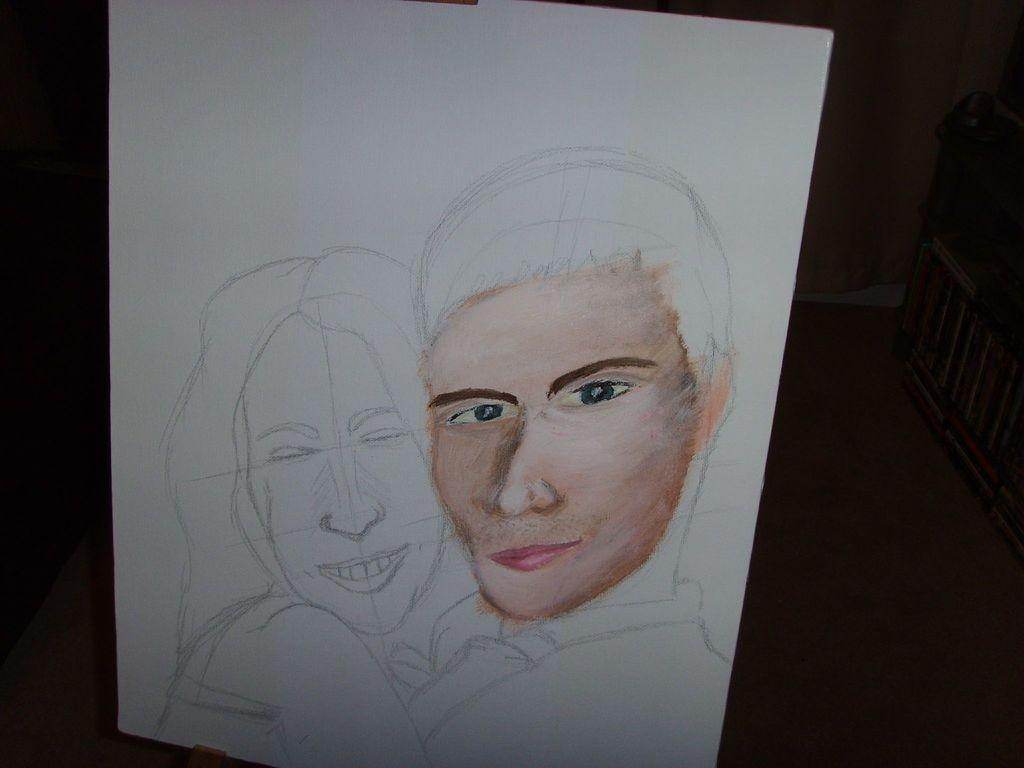What is the main subject of the image? The main subject of the image is a paper. What is depicted on the paper? The paper contains a sketch of a lady and a man. How would you describe the lighting in the image? The background of the image is dark. What grade did the artist receive for their sketch of the lady and man? There is no information about the artist's grade in the image. --- Facts: 1. There is a car in the image. 2. The car is parked on the street. 3. There are trees in the background of the image. 4. The sky is visible in the image. Absurd Topics: dance, ocean, jump Conversation: What is the main subject of the image? The main subject of the image is a car. Where is the car located in the image? The car is parked on the street. What can be seen in the background of the image? There are trees in the background of the image. What is visible at the top of the image? The sky is visible in the image. Reasoning: Let's think step by step in order to produce the conversation. We start by identifying the main subject of the image, which is the car. Then, we describe the location of the car, noting that it is parked on the street. Next, we address the background of the image, which includes trees. Finally, we mention the sky, which is visible at the top of the image. Absurd Question/Answer: Can you see the ocean in the background of the image? No, there is no ocean visible in the image; only trees and the sky can be seen in the background. --- Facts: 1. There is a person in the image. 2. The person is wearing a hat. 3. The person is holding a book. 4. There is a table in the image. 5. The table has a lamp on it. Absurd Topics: swim, fly, bark Conversation: What is the main subject of the image? The main subject of the image is a person. What is the person wearing in the image? The person is wearing a hat. What is the person holding in the image? The person is holding a book. What object can be seen on the table in the image? There is a lamp on the table in the image. Reasoning: Let's think step by step in order to produce the conversation. We start by identifying the main subject of the image, which is the person. Then, we describe the person's attire, noting that they are wearing a hat. Next, we address the object the person is holding, which is a book. Finally, we mention the table and its contents, specifically the lamp. Absurd Question/Answer: Can you hear the person barking in the image? No, there is 